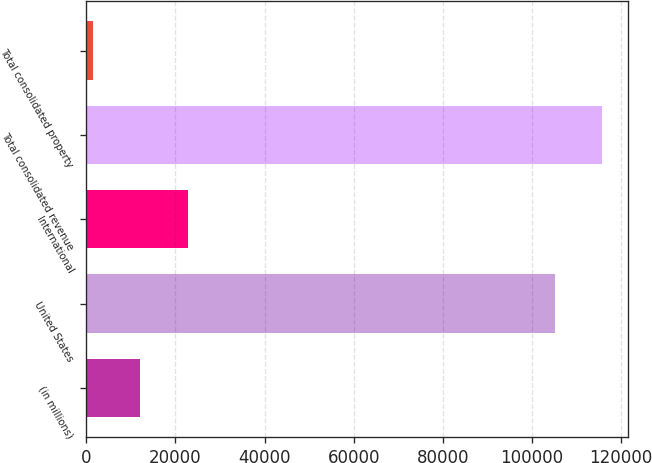Convert chart to OTSL. <chart><loc_0><loc_0><loc_500><loc_500><bar_chart><fcel>(in millions)<fcel>United States<fcel>International<fcel>Total consolidated revenue<fcel>Total consolidated property<nl><fcel>12151.1<fcel>105205<fcel>22751.2<fcel>115805<fcel>1551<nl></chart> 